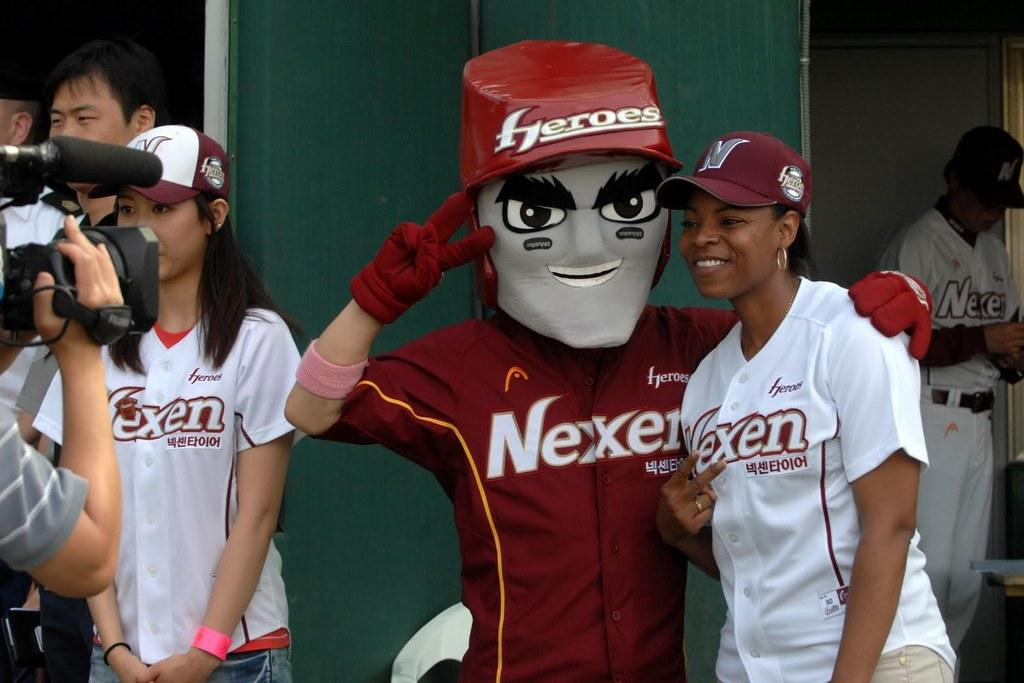<image>
Share a concise interpretation of the image provided. A woman standing next to a mascot for Nexen. 